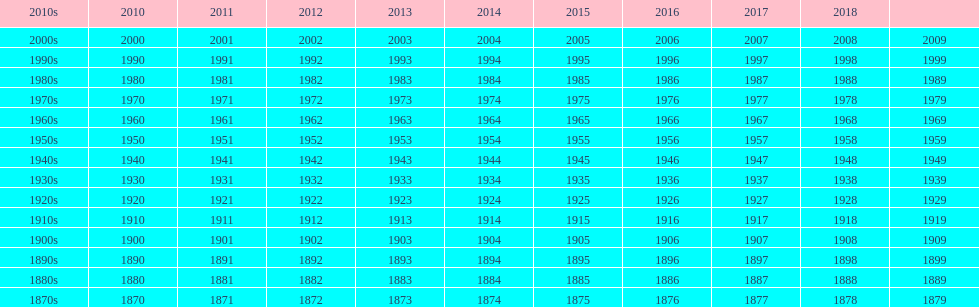Mathematically speaking, what is the difference between 2015 and 1912? 103. 